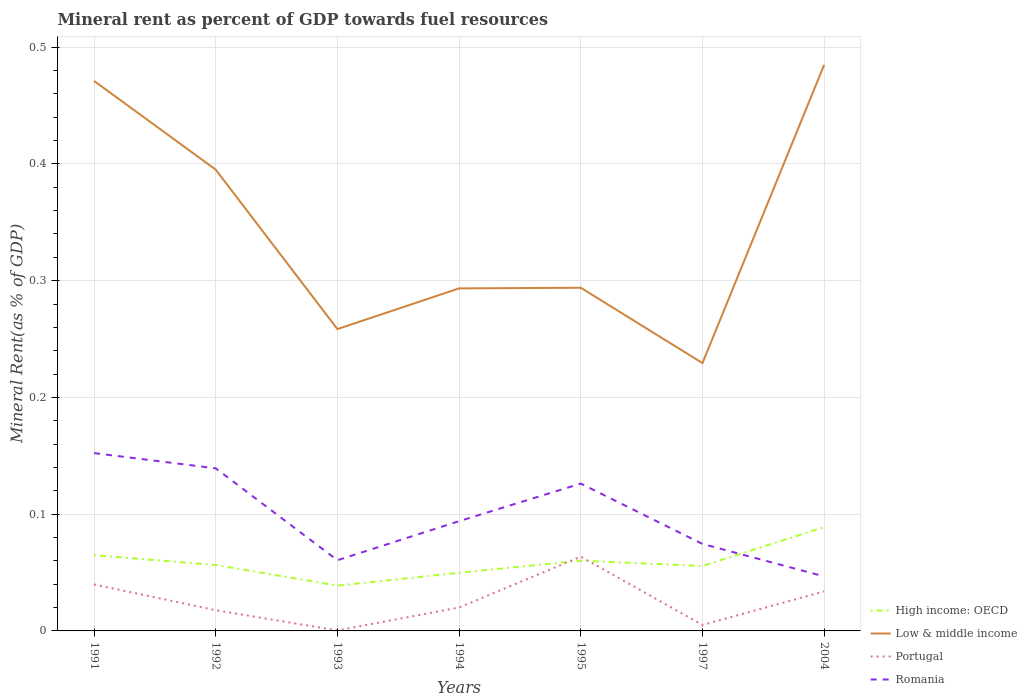Does the line corresponding to High income: OECD intersect with the line corresponding to Romania?
Provide a succinct answer. Yes. Is the number of lines equal to the number of legend labels?
Offer a very short reply. Yes. Across all years, what is the maximum mineral rent in Low & middle income?
Provide a succinct answer. 0.23. In which year was the mineral rent in High income: OECD maximum?
Make the answer very short. 1993. What is the total mineral rent in Romania in the graph?
Offer a terse response. 0.01. What is the difference between the highest and the second highest mineral rent in High income: OECD?
Provide a short and direct response. 0.05. Is the mineral rent in Romania strictly greater than the mineral rent in Low & middle income over the years?
Offer a terse response. Yes. How many lines are there?
Provide a short and direct response. 4. Are the values on the major ticks of Y-axis written in scientific E-notation?
Your answer should be compact. No. Does the graph contain grids?
Offer a very short reply. Yes. Where does the legend appear in the graph?
Your response must be concise. Bottom right. How many legend labels are there?
Make the answer very short. 4. How are the legend labels stacked?
Offer a very short reply. Vertical. What is the title of the graph?
Keep it short and to the point. Mineral rent as percent of GDP towards fuel resources. What is the label or title of the Y-axis?
Your answer should be very brief. Mineral Rent(as % of GDP). What is the Mineral Rent(as % of GDP) in High income: OECD in 1991?
Ensure brevity in your answer.  0.06. What is the Mineral Rent(as % of GDP) in Low & middle income in 1991?
Your response must be concise. 0.47. What is the Mineral Rent(as % of GDP) in Portugal in 1991?
Your answer should be compact. 0.04. What is the Mineral Rent(as % of GDP) of Romania in 1991?
Your answer should be compact. 0.15. What is the Mineral Rent(as % of GDP) in High income: OECD in 1992?
Your answer should be compact. 0.06. What is the Mineral Rent(as % of GDP) of Low & middle income in 1992?
Your answer should be very brief. 0.4. What is the Mineral Rent(as % of GDP) of Portugal in 1992?
Your response must be concise. 0.02. What is the Mineral Rent(as % of GDP) in Romania in 1992?
Provide a short and direct response. 0.14. What is the Mineral Rent(as % of GDP) of High income: OECD in 1993?
Make the answer very short. 0.04. What is the Mineral Rent(as % of GDP) of Low & middle income in 1993?
Your response must be concise. 0.26. What is the Mineral Rent(as % of GDP) of Portugal in 1993?
Your response must be concise. 0. What is the Mineral Rent(as % of GDP) in Romania in 1993?
Your answer should be very brief. 0.06. What is the Mineral Rent(as % of GDP) in High income: OECD in 1994?
Give a very brief answer. 0.05. What is the Mineral Rent(as % of GDP) of Low & middle income in 1994?
Your answer should be very brief. 0.29. What is the Mineral Rent(as % of GDP) of Portugal in 1994?
Ensure brevity in your answer.  0.02. What is the Mineral Rent(as % of GDP) of Romania in 1994?
Your response must be concise. 0.09. What is the Mineral Rent(as % of GDP) of High income: OECD in 1995?
Offer a terse response. 0.06. What is the Mineral Rent(as % of GDP) of Low & middle income in 1995?
Offer a terse response. 0.29. What is the Mineral Rent(as % of GDP) in Portugal in 1995?
Offer a terse response. 0.06. What is the Mineral Rent(as % of GDP) in Romania in 1995?
Give a very brief answer. 0.13. What is the Mineral Rent(as % of GDP) in High income: OECD in 1997?
Your answer should be very brief. 0.06. What is the Mineral Rent(as % of GDP) in Low & middle income in 1997?
Keep it short and to the point. 0.23. What is the Mineral Rent(as % of GDP) in Portugal in 1997?
Your response must be concise. 0.01. What is the Mineral Rent(as % of GDP) in Romania in 1997?
Provide a short and direct response. 0.07. What is the Mineral Rent(as % of GDP) of High income: OECD in 2004?
Keep it short and to the point. 0.09. What is the Mineral Rent(as % of GDP) of Low & middle income in 2004?
Your answer should be very brief. 0.48. What is the Mineral Rent(as % of GDP) of Portugal in 2004?
Offer a very short reply. 0.03. What is the Mineral Rent(as % of GDP) of Romania in 2004?
Ensure brevity in your answer.  0.05. Across all years, what is the maximum Mineral Rent(as % of GDP) of High income: OECD?
Keep it short and to the point. 0.09. Across all years, what is the maximum Mineral Rent(as % of GDP) of Low & middle income?
Your response must be concise. 0.48. Across all years, what is the maximum Mineral Rent(as % of GDP) of Portugal?
Your response must be concise. 0.06. Across all years, what is the maximum Mineral Rent(as % of GDP) of Romania?
Give a very brief answer. 0.15. Across all years, what is the minimum Mineral Rent(as % of GDP) of High income: OECD?
Your answer should be compact. 0.04. Across all years, what is the minimum Mineral Rent(as % of GDP) in Low & middle income?
Your response must be concise. 0.23. Across all years, what is the minimum Mineral Rent(as % of GDP) of Portugal?
Offer a very short reply. 0. Across all years, what is the minimum Mineral Rent(as % of GDP) in Romania?
Provide a short and direct response. 0.05. What is the total Mineral Rent(as % of GDP) in High income: OECD in the graph?
Your response must be concise. 0.41. What is the total Mineral Rent(as % of GDP) in Low & middle income in the graph?
Offer a very short reply. 2.43. What is the total Mineral Rent(as % of GDP) in Portugal in the graph?
Ensure brevity in your answer.  0.18. What is the total Mineral Rent(as % of GDP) of Romania in the graph?
Your answer should be very brief. 0.69. What is the difference between the Mineral Rent(as % of GDP) in High income: OECD in 1991 and that in 1992?
Make the answer very short. 0.01. What is the difference between the Mineral Rent(as % of GDP) in Low & middle income in 1991 and that in 1992?
Your answer should be compact. 0.08. What is the difference between the Mineral Rent(as % of GDP) of Portugal in 1991 and that in 1992?
Offer a terse response. 0.02. What is the difference between the Mineral Rent(as % of GDP) of Romania in 1991 and that in 1992?
Provide a succinct answer. 0.01. What is the difference between the Mineral Rent(as % of GDP) in High income: OECD in 1991 and that in 1993?
Your response must be concise. 0.03. What is the difference between the Mineral Rent(as % of GDP) of Low & middle income in 1991 and that in 1993?
Offer a very short reply. 0.21. What is the difference between the Mineral Rent(as % of GDP) of Portugal in 1991 and that in 1993?
Offer a very short reply. 0.04. What is the difference between the Mineral Rent(as % of GDP) of Romania in 1991 and that in 1993?
Offer a very short reply. 0.09. What is the difference between the Mineral Rent(as % of GDP) in High income: OECD in 1991 and that in 1994?
Give a very brief answer. 0.02. What is the difference between the Mineral Rent(as % of GDP) of Low & middle income in 1991 and that in 1994?
Ensure brevity in your answer.  0.18. What is the difference between the Mineral Rent(as % of GDP) of Portugal in 1991 and that in 1994?
Offer a very short reply. 0.02. What is the difference between the Mineral Rent(as % of GDP) in Romania in 1991 and that in 1994?
Provide a short and direct response. 0.06. What is the difference between the Mineral Rent(as % of GDP) in High income: OECD in 1991 and that in 1995?
Provide a succinct answer. 0. What is the difference between the Mineral Rent(as % of GDP) in Low & middle income in 1991 and that in 1995?
Give a very brief answer. 0.18. What is the difference between the Mineral Rent(as % of GDP) of Portugal in 1991 and that in 1995?
Ensure brevity in your answer.  -0.02. What is the difference between the Mineral Rent(as % of GDP) in Romania in 1991 and that in 1995?
Give a very brief answer. 0.03. What is the difference between the Mineral Rent(as % of GDP) in High income: OECD in 1991 and that in 1997?
Your answer should be very brief. 0.01. What is the difference between the Mineral Rent(as % of GDP) in Low & middle income in 1991 and that in 1997?
Ensure brevity in your answer.  0.24. What is the difference between the Mineral Rent(as % of GDP) of Portugal in 1991 and that in 1997?
Provide a short and direct response. 0.03. What is the difference between the Mineral Rent(as % of GDP) of Romania in 1991 and that in 1997?
Offer a terse response. 0.08. What is the difference between the Mineral Rent(as % of GDP) in High income: OECD in 1991 and that in 2004?
Your response must be concise. -0.02. What is the difference between the Mineral Rent(as % of GDP) of Low & middle income in 1991 and that in 2004?
Ensure brevity in your answer.  -0.01. What is the difference between the Mineral Rent(as % of GDP) in Portugal in 1991 and that in 2004?
Ensure brevity in your answer.  0.01. What is the difference between the Mineral Rent(as % of GDP) of Romania in 1991 and that in 2004?
Your answer should be very brief. 0.11. What is the difference between the Mineral Rent(as % of GDP) in High income: OECD in 1992 and that in 1993?
Offer a very short reply. 0.02. What is the difference between the Mineral Rent(as % of GDP) in Low & middle income in 1992 and that in 1993?
Your answer should be compact. 0.14. What is the difference between the Mineral Rent(as % of GDP) of Portugal in 1992 and that in 1993?
Provide a short and direct response. 0.02. What is the difference between the Mineral Rent(as % of GDP) in Romania in 1992 and that in 1993?
Your answer should be very brief. 0.08. What is the difference between the Mineral Rent(as % of GDP) of High income: OECD in 1992 and that in 1994?
Your response must be concise. 0.01. What is the difference between the Mineral Rent(as % of GDP) of Low & middle income in 1992 and that in 1994?
Offer a terse response. 0.1. What is the difference between the Mineral Rent(as % of GDP) of Portugal in 1992 and that in 1994?
Make the answer very short. -0. What is the difference between the Mineral Rent(as % of GDP) of Romania in 1992 and that in 1994?
Offer a very short reply. 0.05. What is the difference between the Mineral Rent(as % of GDP) in High income: OECD in 1992 and that in 1995?
Provide a succinct answer. -0. What is the difference between the Mineral Rent(as % of GDP) of Low & middle income in 1992 and that in 1995?
Give a very brief answer. 0.1. What is the difference between the Mineral Rent(as % of GDP) in Portugal in 1992 and that in 1995?
Give a very brief answer. -0.05. What is the difference between the Mineral Rent(as % of GDP) in Romania in 1992 and that in 1995?
Make the answer very short. 0.01. What is the difference between the Mineral Rent(as % of GDP) of High income: OECD in 1992 and that in 1997?
Your response must be concise. 0. What is the difference between the Mineral Rent(as % of GDP) in Low & middle income in 1992 and that in 1997?
Provide a succinct answer. 0.17. What is the difference between the Mineral Rent(as % of GDP) in Portugal in 1992 and that in 1997?
Your answer should be compact. 0.01. What is the difference between the Mineral Rent(as % of GDP) in Romania in 1992 and that in 1997?
Keep it short and to the point. 0.06. What is the difference between the Mineral Rent(as % of GDP) in High income: OECD in 1992 and that in 2004?
Make the answer very short. -0.03. What is the difference between the Mineral Rent(as % of GDP) in Low & middle income in 1992 and that in 2004?
Offer a very short reply. -0.09. What is the difference between the Mineral Rent(as % of GDP) of Portugal in 1992 and that in 2004?
Keep it short and to the point. -0.02. What is the difference between the Mineral Rent(as % of GDP) in Romania in 1992 and that in 2004?
Give a very brief answer. 0.09. What is the difference between the Mineral Rent(as % of GDP) of High income: OECD in 1993 and that in 1994?
Keep it short and to the point. -0.01. What is the difference between the Mineral Rent(as % of GDP) in Low & middle income in 1993 and that in 1994?
Offer a terse response. -0.03. What is the difference between the Mineral Rent(as % of GDP) in Portugal in 1993 and that in 1994?
Make the answer very short. -0.02. What is the difference between the Mineral Rent(as % of GDP) in Romania in 1993 and that in 1994?
Provide a short and direct response. -0.03. What is the difference between the Mineral Rent(as % of GDP) in High income: OECD in 1993 and that in 1995?
Ensure brevity in your answer.  -0.02. What is the difference between the Mineral Rent(as % of GDP) in Low & middle income in 1993 and that in 1995?
Keep it short and to the point. -0.04. What is the difference between the Mineral Rent(as % of GDP) in Portugal in 1993 and that in 1995?
Give a very brief answer. -0.06. What is the difference between the Mineral Rent(as % of GDP) of Romania in 1993 and that in 1995?
Keep it short and to the point. -0.07. What is the difference between the Mineral Rent(as % of GDP) in High income: OECD in 1993 and that in 1997?
Give a very brief answer. -0.02. What is the difference between the Mineral Rent(as % of GDP) of Low & middle income in 1993 and that in 1997?
Your response must be concise. 0.03. What is the difference between the Mineral Rent(as % of GDP) in Portugal in 1993 and that in 1997?
Your answer should be compact. -0. What is the difference between the Mineral Rent(as % of GDP) in Romania in 1993 and that in 1997?
Offer a terse response. -0.01. What is the difference between the Mineral Rent(as % of GDP) of High income: OECD in 1993 and that in 2004?
Keep it short and to the point. -0.05. What is the difference between the Mineral Rent(as % of GDP) in Low & middle income in 1993 and that in 2004?
Your answer should be compact. -0.23. What is the difference between the Mineral Rent(as % of GDP) in Portugal in 1993 and that in 2004?
Your response must be concise. -0.03. What is the difference between the Mineral Rent(as % of GDP) in Romania in 1993 and that in 2004?
Make the answer very short. 0.01. What is the difference between the Mineral Rent(as % of GDP) of High income: OECD in 1994 and that in 1995?
Your response must be concise. -0.01. What is the difference between the Mineral Rent(as % of GDP) of Low & middle income in 1994 and that in 1995?
Give a very brief answer. -0. What is the difference between the Mineral Rent(as % of GDP) in Portugal in 1994 and that in 1995?
Your answer should be compact. -0.04. What is the difference between the Mineral Rent(as % of GDP) of Romania in 1994 and that in 1995?
Your answer should be compact. -0.03. What is the difference between the Mineral Rent(as % of GDP) of High income: OECD in 1994 and that in 1997?
Your answer should be compact. -0.01. What is the difference between the Mineral Rent(as % of GDP) of Low & middle income in 1994 and that in 1997?
Make the answer very short. 0.06. What is the difference between the Mineral Rent(as % of GDP) in Portugal in 1994 and that in 1997?
Provide a short and direct response. 0.01. What is the difference between the Mineral Rent(as % of GDP) of Romania in 1994 and that in 1997?
Give a very brief answer. 0.02. What is the difference between the Mineral Rent(as % of GDP) of High income: OECD in 1994 and that in 2004?
Your answer should be compact. -0.04. What is the difference between the Mineral Rent(as % of GDP) of Low & middle income in 1994 and that in 2004?
Your answer should be very brief. -0.19. What is the difference between the Mineral Rent(as % of GDP) of Portugal in 1994 and that in 2004?
Give a very brief answer. -0.01. What is the difference between the Mineral Rent(as % of GDP) of Romania in 1994 and that in 2004?
Keep it short and to the point. 0.05. What is the difference between the Mineral Rent(as % of GDP) in High income: OECD in 1995 and that in 1997?
Offer a very short reply. 0. What is the difference between the Mineral Rent(as % of GDP) in Low & middle income in 1995 and that in 1997?
Give a very brief answer. 0.06. What is the difference between the Mineral Rent(as % of GDP) of Portugal in 1995 and that in 1997?
Make the answer very short. 0.06. What is the difference between the Mineral Rent(as % of GDP) in Romania in 1995 and that in 1997?
Provide a succinct answer. 0.05. What is the difference between the Mineral Rent(as % of GDP) of High income: OECD in 1995 and that in 2004?
Provide a short and direct response. -0.03. What is the difference between the Mineral Rent(as % of GDP) of Low & middle income in 1995 and that in 2004?
Provide a succinct answer. -0.19. What is the difference between the Mineral Rent(as % of GDP) in Portugal in 1995 and that in 2004?
Your answer should be compact. 0.03. What is the difference between the Mineral Rent(as % of GDP) of Romania in 1995 and that in 2004?
Offer a very short reply. 0.08. What is the difference between the Mineral Rent(as % of GDP) in High income: OECD in 1997 and that in 2004?
Provide a short and direct response. -0.03. What is the difference between the Mineral Rent(as % of GDP) in Low & middle income in 1997 and that in 2004?
Ensure brevity in your answer.  -0.26. What is the difference between the Mineral Rent(as % of GDP) of Portugal in 1997 and that in 2004?
Make the answer very short. -0.03. What is the difference between the Mineral Rent(as % of GDP) of Romania in 1997 and that in 2004?
Your answer should be very brief. 0.03. What is the difference between the Mineral Rent(as % of GDP) of High income: OECD in 1991 and the Mineral Rent(as % of GDP) of Low & middle income in 1992?
Your response must be concise. -0.33. What is the difference between the Mineral Rent(as % of GDP) of High income: OECD in 1991 and the Mineral Rent(as % of GDP) of Portugal in 1992?
Your response must be concise. 0.05. What is the difference between the Mineral Rent(as % of GDP) of High income: OECD in 1991 and the Mineral Rent(as % of GDP) of Romania in 1992?
Provide a succinct answer. -0.07. What is the difference between the Mineral Rent(as % of GDP) of Low & middle income in 1991 and the Mineral Rent(as % of GDP) of Portugal in 1992?
Give a very brief answer. 0.45. What is the difference between the Mineral Rent(as % of GDP) of Low & middle income in 1991 and the Mineral Rent(as % of GDP) of Romania in 1992?
Offer a terse response. 0.33. What is the difference between the Mineral Rent(as % of GDP) in Portugal in 1991 and the Mineral Rent(as % of GDP) in Romania in 1992?
Your answer should be very brief. -0.1. What is the difference between the Mineral Rent(as % of GDP) in High income: OECD in 1991 and the Mineral Rent(as % of GDP) in Low & middle income in 1993?
Offer a terse response. -0.19. What is the difference between the Mineral Rent(as % of GDP) in High income: OECD in 1991 and the Mineral Rent(as % of GDP) in Portugal in 1993?
Provide a succinct answer. 0.06. What is the difference between the Mineral Rent(as % of GDP) of High income: OECD in 1991 and the Mineral Rent(as % of GDP) of Romania in 1993?
Give a very brief answer. 0. What is the difference between the Mineral Rent(as % of GDP) of Low & middle income in 1991 and the Mineral Rent(as % of GDP) of Portugal in 1993?
Your response must be concise. 0.47. What is the difference between the Mineral Rent(as % of GDP) in Low & middle income in 1991 and the Mineral Rent(as % of GDP) in Romania in 1993?
Ensure brevity in your answer.  0.41. What is the difference between the Mineral Rent(as % of GDP) in Portugal in 1991 and the Mineral Rent(as % of GDP) in Romania in 1993?
Provide a succinct answer. -0.02. What is the difference between the Mineral Rent(as % of GDP) in High income: OECD in 1991 and the Mineral Rent(as % of GDP) in Low & middle income in 1994?
Make the answer very short. -0.23. What is the difference between the Mineral Rent(as % of GDP) in High income: OECD in 1991 and the Mineral Rent(as % of GDP) in Portugal in 1994?
Offer a very short reply. 0.04. What is the difference between the Mineral Rent(as % of GDP) in High income: OECD in 1991 and the Mineral Rent(as % of GDP) in Romania in 1994?
Your answer should be very brief. -0.03. What is the difference between the Mineral Rent(as % of GDP) of Low & middle income in 1991 and the Mineral Rent(as % of GDP) of Portugal in 1994?
Give a very brief answer. 0.45. What is the difference between the Mineral Rent(as % of GDP) in Low & middle income in 1991 and the Mineral Rent(as % of GDP) in Romania in 1994?
Keep it short and to the point. 0.38. What is the difference between the Mineral Rent(as % of GDP) of Portugal in 1991 and the Mineral Rent(as % of GDP) of Romania in 1994?
Your response must be concise. -0.05. What is the difference between the Mineral Rent(as % of GDP) of High income: OECD in 1991 and the Mineral Rent(as % of GDP) of Low & middle income in 1995?
Your answer should be compact. -0.23. What is the difference between the Mineral Rent(as % of GDP) of High income: OECD in 1991 and the Mineral Rent(as % of GDP) of Portugal in 1995?
Keep it short and to the point. 0. What is the difference between the Mineral Rent(as % of GDP) in High income: OECD in 1991 and the Mineral Rent(as % of GDP) in Romania in 1995?
Provide a succinct answer. -0.06. What is the difference between the Mineral Rent(as % of GDP) of Low & middle income in 1991 and the Mineral Rent(as % of GDP) of Portugal in 1995?
Provide a short and direct response. 0.41. What is the difference between the Mineral Rent(as % of GDP) of Low & middle income in 1991 and the Mineral Rent(as % of GDP) of Romania in 1995?
Ensure brevity in your answer.  0.34. What is the difference between the Mineral Rent(as % of GDP) in Portugal in 1991 and the Mineral Rent(as % of GDP) in Romania in 1995?
Keep it short and to the point. -0.09. What is the difference between the Mineral Rent(as % of GDP) of High income: OECD in 1991 and the Mineral Rent(as % of GDP) of Low & middle income in 1997?
Keep it short and to the point. -0.16. What is the difference between the Mineral Rent(as % of GDP) of High income: OECD in 1991 and the Mineral Rent(as % of GDP) of Portugal in 1997?
Your response must be concise. 0.06. What is the difference between the Mineral Rent(as % of GDP) in High income: OECD in 1991 and the Mineral Rent(as % of GDP) in Romania in 1997?
Offer a very short reply. -0.01. What is the difference between the Mineral Rent(as % of GDP) in Low & middle income in 1991 and the Mineral Rent(as % of GDP) in Portugal in 1997?
Your response must be concise. 0.47. What is the difference between the Mineral Rent(as % of GDP) in Low & middle income in 1991 and the Mineral Rent(as % of GDP) in Romania in 1997?
Your answer should be very brief. 0.4. What is the difference between the Mineral Rent(as % of GDP) of Portugal in 1991 and the Mineral Rent(as % of GDP) of Romania in 1997?
Provide a succinct answer. -0.03. What is the difference between the Mineral Rent(as % of GDP) in High income: OECD in 1991 and the Mineral Rent(as % of GDP) in Low & middle income in 2004?
Make the answer very short. -0.42. What is the difference between the Mineral Rent(as % of GDP) in High income: OECD in 1991 and the Mineral Rent(as % of GDP) in Portugal in 2004?
Provide a succinct answer. 0.03. What is the difference between the Mineral Rent(as % of GDP) of High income: OECD in 1991 and the Mineral Rent(as % of GDP) of Romania in 2004?
Give a very brief answer. 0.02. What is the difference between the Mineral Rent(as % of GDP) of Low & middle income in 1991 and the Mineral Rent(as % of GDP) of Portugal in 2004?
Your response must be concise. 0.44. What is the difference between the Mineral Rent(as % of GDP) in Low & middle income in 1991 and the Mineral Rent(as % of GDP) in Romania in 2004?
Give a very brief answer. 0.42. What is the difference between the Mineral Rent(as % of GDP) of Portugal in 1991 and the Mineral Rent(as % of GDP) of Romania in 2004?
Offer a terse response. -0.01. What is the difference between the Mineral Rent(as % of GDP) in High income: OECD in 1992 and the Mineral Rent(as % of GDP) in Low & middle income in 1993?
Ensure brevity in your answer.  -0.2. What is the difference between the Mineral Rent(as % of GDP) in High income: OECD in 1992 and the Mineral Rent(as % of GDP) in Portugal in 1993?
Your response must be concise. 0.06. What is the difference between the Mineral Rent(as % of GDP) in High income: OECD in 1992 and the Mineral Rent(as % of GDP) in Romania in 1993?
Provide a succinct answer. -0. What is the difference between the Mineral Rent(as % of GDP) in Low & middle income in 1992 and the Mineral Rent(as % of GDP) in Portugal in 1993?
Your answer should be compact. 0.39. What is the difference between the Mineral Rent(as % of GDP) of Low & middle income in 1992 and the Mineral Rent(as % of GDP) of Romania in 1993?
Your response must be concise. 0.33. What is the difference between the Mineral Rent(as % of GDP) of Portugal in 1992 and the Mineral Rent(as % of GDP) of Romania in 1993?
Offer a very short reply. -0.04. What is the difference between the Mineral Rent(as % of GDP) of High income: OECD in 1992 and the Mineral Rent(as % of GDP) of Low & middle income in 1994?
Give a very brief answer. -0.24. What is the difference between the Mineral Rent(as % of GDP) of High income: OECD in 1992 and the Mineral Rent(as % of GDP) of Portugal in 1994?
Your answer should be compact. 0.04. What is the difference between the Mineral Rent(as % of GDP) in High income: OECD in 1992 and the Mineral Rent(as % of GDP) in Romania in 1994?
Offer a very short reply. -0.04. What is the difference between the Mineral Rent(as % of GDP) of Low & middle income in 1992 and the Mineral Rent(as % of GDP) of Romania in 1994?
Offer a very short reply. 0.3. What is the difference between the Mineral Rent(as % of GDP) in Portugal in 1992 and the Mineral Rent(as % of GDP) in Romania in 1994?
Your response must be concise. -0.08. What is the difference between the Mineral Rent(as % of GDP) of High income: OECD in 1992 and the Mineral Rent(as % of GDP) of Low & middle income in 1995?
Provide a short and direct response. -0.24. What is the difference between the Mineral Rent(as % of GDP) in High income: OECD in 1992 and the Mineral Rent(as % of GDP) in Portugal in 1995?
Provide a succinct answer. -0.01. What is the difference between the Mineral Rent(as % of GDP) in High income: OECD in 1992 and the Mineral Rent(as % of GDP) in Romania in 1995?
Your answer should be very brief. -0.07. What is the difference between the Mineral Rent(as % of GDP) in Low & middle income in 1992 and the Mineral Rent(as % of GDP) in Portugal in 1995?
Your answer should be compact. 0.33. What is the difference between the Mineral Rent(as % of GDP) of Low & middle income in 1992 and the Mineral Rent(as % of GDP) of Romania in 1995?
Give a very brief answer. 0.27. What is the difference between the Mineral Rent(as % of GDP) in Portugal in 1992 and the Mineral Rent(as % of GDP) in Romania in 1995?
Your answer should be compact. -0.11. What is the difference between the Mineral Rent(as % of GDP) in High income: OECD in 1992 and the Mineral Rent(as % of GDP) in Low & middle income in 1997?
Offer a very short reply. -0.17. What is the difference between the Mineral Rent(as % of GDP) of High income: OECD in 1992 and the Mineral Rent(as % of GDP) of Portugal in 1997?
Ensure brevity in your answer.  0.05. What is the difference between the Mineral Rent(as % of GDP) of High income: OECD in 1992 and the Mineral Rent(as % of GDP) of Romania in 1997?
Provide a succinct answer. -0.02. What is the difference between the Mineral Rent(as % of GDP) of Low & middle income in 1992 and the Mineral Rent(as % of GDP) of Portugal in 1997?
Your answer should be compact. 0.39. What is the difference between the Mineral Rent(as % of GDP) of Low & middle income in 1992 and the Mineral Rent(as % of GDP) of Romania in 1997?
Provide a short and direct response. 0.32. What is the difference between the Mineral Rent(as % of GDP) of Portugal in 1992 and the Mineral Rent(as % of GDP) of Romania in 1997?
Ensure brevity in your answer.  -0.06. What is the difference between the Mineral Rent(as % of GDP) in High income: OECD in 1992 and the Mineral Rent(as % of GDP) in Low & middle income in 2004?
Provide a succinct answer. -0.43. What is the difference between the Mineral Rent(as % of GDP) in High income: OECD in 1992 and the Mineral Rent(as % of GDP) in Portugal in 2004?
Offer a terse response. 0.02. What is the difference between the Mineral Rent(as % of GDP) in High income: OECD in 1992 and the Mineral Rent(as % of GDP) in Romania in 2004?
Provide a succinct answer. 0.01. What is the difference between the Mineral Rent(as % of GDP) in Low & middle income in 1992 and the Mineral Rent(as % of GDP) in Portugal in 2004?
Provide a short and direct response. 0.36. What is the difference between the Mineral Rent(as % of GDP) of Low & middle income in 1992 and the Mineral Rent(as % of GDP) of Romania in 2004?
Your answer should be very brief. 0.35. What is the difference between the Mineral Rent(as % of GDP) in Portugal in 1992 and the Mineral Rent(as % of GDP) in Romania in 2004?
Provide a succinct answer. -0.03. What is the difference between the Mineral Rent(as % of GDP) in High income: OECD in 1993 and the Mineral Rent(as % of GDP) in Low & middle income in 1994?
Keep it short and to the point. -0.25. What is the difference between the Mineral Rent(as % of GDP) in High income: OECD in 1993 and the Mineral Rent(as % of GDP) in Portugal in 1994?
Give a very brief answer. 0.02. What is the difference between the Mineral Rent(as % of GDP) of High income: OECD in 1993 and the Mineral Rent(as % of GDP) of Romania in 1994?
Make the answer very short. -0.06. What is the difference between the Mineral Rent(as % of GDP) of Low & middle income in 1993 and the Mineral Rent(as % of GDP) of Portugal in 1994?
Make the answer very short. 0.24. What is the difference between the Mineral Rent(as % of GDP) of Low & middle income in 1993 and the Mineral Rent(as % of GDP) of Romania in 1994?
Keep it short and to the point. 0.16. What is the difference between the Mineral Rent(as % of GDP) in Portugal in 1993 and the Mineral Rent(as % of GDP) in Romania in 1994?
Your answer should be compact. -0.09. What is the difference between the Mineral Rent(as % of GDP) in High income: OECD in 1993 and the Mineral Rent(as % of GDP) in Low & middle income in 1995?
Provide a succinct answer. -0.26. What is the difference between the Mineral Rent(as % of GDP) of High income: OECD in 1993 and the Mineral Rent(as % of GDP) of Portugal in 1995?
Ensure brevity in your answer.  -0.02. What is the difference between the Mineral Rent(as % of GDP) in High income: OECD in 1993 and the Mineral Rent(as % of GDP) in Romania in 1995?
Make the answer very short. -0.09. What is the difference between the Mineral Rent(as % of GDP) of Low & middle income in 1993 and the Mineral Rent(as % of GDP) of Portugal in 1995?
Offer a very short reply. 0.19. What is the difference between the Mineral Rent(as % of GDP) of Low & middle income in 1993 and the Mineral Rent(as % of GDP) of Romania in 1995?
Provide a short and direct response. 0.13. What is the difference between the Mineral Rent(as % of GDP) of Portugal in 1993 and the Mineral Rent(as % of GDP) of Romania in 1995?
Keep it short and to the point. -0.13. What is the difference between the Mineral Rent(as % of GDP) of High income: OECD in 1993 and the Mineral Rent(as % of GDP) of Low & middle income in 1997?
Give a very brief answer. -0.19. What is the difference between the Mineral Rent(as % of GDP) of High income: OECD in 1993 and the Mineral Rent(as % of GDP) of Portugal in 1997?
Your answer should be very brief. 0.03. What is the difference between the Mineral Rent(as % of GDP) in High income: OECD in 1993 and the Mineral Rent(as % of GDP) in Romania in 1997?
Offer a terse response. -0.04. What is the difference between the Mineral Rent(as % of GDP) of Low & middle income in 1993 and the Mineral Rent(as % of GDP) of Portugal in 1997?
Keep it short and to the point. 0.25. What is the difference between the Mineral Rent(as % of GDP) in Low & middle income in 1993 and the Mineral Rent(as % of GDP) in Romania in 1997?
Your answer should be compact. 0.18. What is the difference between the Mineral Rent(as % of GDP) of Portugal in 1993 and the Mineral Rent(as % of GDP) of Romania in 1997?
Your answer should be very brief. -0.07. What is the difference between the Mineral Rent(as % of GDP) of High income: OECD in 1993 and the Mineral Rent(as % of GDP) of Low & middle income in 2004?
Provide a succinct answer. -0.45. What is the difference between the Mineral Rent(as % of GDP) of High income: OECD in 1993 and the Mineral Rent(as % of GDP) of Portugal in 2004?
Your answer should be very brief. 0.01. What is the difference between the Mineral Rent(as % of GDP) of High income: OECD in 1993 and the Mineral Rent(as % of GDP) of Romania in 2004?
Your answer should be very brief. -0.01. What is the difference between the Mineral Rent(as % of GDP) of Low & middle income in 1993 and the Mineral Rent(as % of GDP) of Portugal in 2004?
Provide a short and direct response. 0.22. What is the difference between the Mineral Rent(as % of GDP) of Low & middle income in 1993 and the Mineral Rent(as % of GDP) of Romania in 2004?
Make the answer very short. 0.21. What is the difference between the Mineral Rent(as % of GDP) in Portugal in 1993 and the Mineral Rent(as % of GDP) in Romania in 2004?
Provide a short and direct response. -0.05. What is the difference between the Mineral Rent(as % of GDP) of High income: OECD in 1994 and the Mineral Rent(as % of GDP) of Low & middle income in 1995?
Your response must be concise. -0.24. What is the difference between the Mineral Rent(as % of GDP) of High income: OECD in 1994 and the Mineral Rent(as % of GDP) of Portugal in 1995?
Your answer should be very brief. -0.01. What is the difference between the Mineral Rent(as % of GDP) in High income: OECD in 1994 and the Mineral Rent(as % of GDP) in Romania in 1995?
Your answer should be compact. -0.08. What is the difference between the Mineral Rent(as % of GDP) in Low & middle income in 1994 and the Mineral Rent(as % of GDP) in Portugal in 1995?
Give a very brief answer. 0.23. What is the difference between the Mineral Rent(as % of GDP) of Low & middle income in 1994 and the Mineral Rent(as % of GDP) of Romania in 1995?
Provide a succinct answer. 0.17. What is the difference between the Mineral Rent(as % of GDP) in Portugal in 1994 and the Mineral Rent(as % of GDP) in Romania in 1995?
Ensure brevity in your answer.  -0.11. What is the difference between the Mineral Rent(as % of GDP) in High income: OECD in 1994 and the Mineral Rent(as % of GDP) in Low & middle income in 1997?
Keep it short and to the point. -0.18. What is the difference between the Mineral Rent(as % of GDP) in High income: OECD in 1994 and the Mineral Rent(as % of GDP) in Portugal in 1997?
Ensure brevity in your answer.  0.04. What is the difference between the Mineral Rent(as % of GDP) of High income: OECD in 1994 and the Mineral Rent(as % of GDP) of Romania in 1997?
Your response must be concise. -0.02. What is the difference between the Mineral Rent(as % of GDP) of Low & middle income in 1994 and the Mineral Rent(as % of GDP) of Portugal in 1997?
Make the answer very short. 0.29. What is the difference between the Mineral Rent(as % of GDP) of Low & middle income in 1994 and the Mineral Rent(as % of GDP) of Romania in 1997?
Provide a short and direct response. 0.22. What is the difference between the Mineral Rent(as % of GDP) of Portugal in 1994 and the Mineral Rent(as % of GDP) of Romania in 1997?
Offer a very short reply. -0.05. What is the difference between the Mineral Rent(as % of GDP) in High income: OECD in 1994 and the Mineral Rent(as % of GDP) in Low & middle income in 2004?
Offer a very short reply. -0.43. What is the difference between the Mineral Rent(as % of GDP) of High income: OECD in 1994 and the Mineral Rent(as % of GDP) of Portugal in 2004?
Your answer should be very brief. 0.02. What is the difference between the Mineral Rent(as % of GDP) of High income: OECD in 1994 and the Mineral Rent(as % of GDP) of Romania in 2004?
Give a very brief answer. 0. What is the difference between the Mineral Rent(as % of GDP) of Low & middle income in 1994 and the Mineral Rent(as % of GDP) of Portugal in 2004?
Offer a very short reply. 0.26. What is the difference between the Mineral Rent(as % of GDP) in Low & middle income in 1994 and the Mineral Rent(as % of GDP) in Romania in 2004?
Ensure brevity in your answer.  0.25. What is the difference between the Mineral Rent(as % of GDP) in Portugal in 1994 and the Mineral Rent(as % of GDP) in Romania in 2004?
Your answer should be compact. -0.03. What is the difference between the Mineral Rent(as % of GDP) in High income: OECD in 1995 and the Mineral Rent(as % of GDP) in Low & middle income in 1997?
Offer a terse response. -0.17. What is the difference between the Mineral Rent(as % of GDP) of High income: OECD in 1995 and the Mineral Rent(as % of GDP) of Portugal in 1997?
Provide a succinct answer. 0.06. What is the difference between the Mineral Rent(as % of GDP) in High income: OECD in 1995 and the Mineral Rent(as % of GDP) in Romania in 1997?
Offer a terse response. -0.01. What is the difference between the Mineral Rent(as % of GDP) of Low & middle income in 1995 and the Mineral Rent(as % of GDP) of Portugal in 1997?
Provide a succinct answer. 0.29. What is the difference between the Mineral Rent(as % of GDP) in Low & middle income in 1995 and the Mineral Rent(as % of GDP) in Romania in 1997?
Make the answer very short. 0.22. What is the difference between the Mineral Rent(as % of GDP) in Portugal in 1995 and the Mineral Rent(as % of GDP) in Romania in 1997?
Ensure brevity in your answer.  -0.01. What is the difference between the Mineral Rent(as % of GDP) in High income: OECD in 1995 and the Mineral Rent(as % of GDP) in Low & middle income in 2004?
Your answer should be very brief. -0.42. What is the difference between the Mineral Rent(as % of GDP) of High income: OECD in 1995 and the Mineral Rent(as % of GDP) of Portugal in 2004?
Your answer should be very brief. 0.03. What is the difference between the Mineral Rent(as % of GDP) of High income: OECD in 1995 and the Mineral Rent(as % of GDP) of Romania in 2004?
Provide a succinct answer. 0.01. What is the difference between the Mineral Rent(as % of GDP) of Low & middle income in 1995 and the Mineral Rent(as % of GDP) of Portugal in 2004?
Keep it short and to the point. 0.26. What is the difference between the Mineral Rent(as % of GDP) in Low & middle income in 1995 and the Mineral Rent(as % of GDP) in Romania in 2004?
Keep it short and to the point. 0.25. What is the difference between the Mineral Rent(as % of GDP) of Portugal in 1995 and the Mineral Rent(as % of GDP) of Romania in 2004?
Your response must be concise. 0.02. What is the difference between the Mineral Rent(as % of GDP) in High income: OECD in 1997 and the Mineral Rent(as % of GDP) in Low & middle income in 2004?
Keep it short and to the point. -0.43. What is the difference between the Mineral Rent(as % of GDP) in High income: OECD in 1997 and the Mineral Rent(as % of GDP) in Portugal in 2004?
Give a very brief answer. 0.02. What is the difference between the Mineral Rent(as % of GDP) of High income: OECD in 1997 and the Mineral Rent(as % of GDP) of Romania in 2004?
Make the answer very short. 0.01. What is the difference between the Mineral Rent(as % of GDP) of Low & middle income in 1997 and the Mineral Rent(as % of GDP) of Portugal in 2004?
Your response must be concise. 0.2. What is the difference between the Mineral Rent(as % of GDP) of Low & middle income in 1997 and the Mineral Rent(as % of GDP) of Romania in 2004?
Your response must be concise. 0.18. What is the difference between the Mineral Rent(as % of GDP) of Portugal in 1997 and the Mineral Rent(as % of GDP) of Romania in 2004?
Provide a short and direct response. -0.04. What is the average Mineral Rent(as % of GDP) of High income: OECD per year?
Give a very brief answer. 0.06. What is the average Mineral Rent(as % of GDP) in Low & middle income per year?
Keep it short and to the point. 0.35. What is the average Mineral Rent(as % of GDP) in Portugal per year?
Make the answer very short. 0.03. What is the average Mineral Rent(as % of GDP) in Romania per year?
Your answer should be very brief. 0.1. In the year 1991, what is the difference between the Mineral Rent(as % of GDP) in High income: OECD and Mineral Rent(as % of GDP) in Low & middle income?
Provide a short and direct response. -0.41. In the year 1991, what is the difference between the Mineral Rent(as % of GDP) in High income: OECD and Mineral Rent(as % of GDP) in Portugal?
Provide a succinct answer. 0.03. In the year 1991, what is the difference between the Mineral Rent(as % of GDP) in High income: OECD and Mineral Rent(as % of GDP) in Romania?
Make the answer very short. -0.09. In the year 1991, what is the difference between the Mineral Rent(as % of GDP) in Low & middle income and Mineral Rent(as % of GDP) in Portugal?
Your answer should be compact. 0.43. In the year 1991, what is the difference between the Mineral Rent(as % of GDP) in Low & middle income and Mineral Rent(as % of GDP) in Romania?
Ensure brevity in your answer.  0.32. In the year 1991, what is the difference between the Mineral Rent(as % of GDP) of Portugal and Mineral Rent(as % of GDP) of Romania?
Offer a terse response. -0.11. In the year 1992, what is the difference between the Mineral Rent(as % of GDP) of High income: OECD and Mineral Rent(as % of GDP) of Low & middle income?
Your answer should be very brief. -0.34. In the year 1992, what is the difference between the Mineral Rent(as % of GDP) in High income: OECD and Mineral Rent(as % of GDP) in Portugal?
Offer a very short reply. 0.04. In the year 1992, what is the difference between the Mineral Rent(as % of GDP) of High income: OECD and Mineral Rent(as % of GDP) of Romania?
Offer a terse response. -0.08. In the year 1992, what is the difference between the Mineral Rent(as % of GDP) of Low & middle income and Mineral Rent(as % of GDP) of Portugal?
Provide a succinct answer. 0.38. In the year 1992, what is the difference between the Mineral Rent(as % of GDP) of Low & middle income and Mineral Rent(as % of GDP) of Romania?
Your answer should be very brief. 0.26. In the year 1992, what is the difference between the Mineral Rent(as % of GDP) of Portugal and Mineral Rent(as % of GDP) of Romania?
Keep it short and to the point. -0.12. In the year 1993, what is the difference between the Mineral Rent(as % of GDP) of High income: OECD and Mineral Rent(as % of GDP) of Low & middle income?
Provide a succinct answer. -0.22. In the year 1993, what is the difference between the Mineral Rent(as % of GDP) of High income: OECD and Mineral Rent(as % of GDP) of Portugal?
Your answer should be very brief. 0.04. In the year 1993, what is the difference between the Mineral Rent(as % of GDP) of High income: OECD and Mineral Rent(as % of GDP) of Romania?
Give a very brief answer. -0.02. In the year 1993, what is the difference between the Mineral Rent(as % of GDP) in Low & middle income and Mineral Rent(as % of GDP) in Portugal?
Provide a short and direct response. 0.26. In the year 1993, what is the difference between the Mineral Rent(as % of GDP) in Low & middle income and Mineral Rent(as % of GDP) in Romania?
Provide a succinct answer. 0.2. In the year 1993, what is the difference between the Mineral Rent(as % of GDP) of Portugal and Mineral Rent(as % of GDP) of Romania?
Your answer should be very brief. -0.06. In the year 1994, what is the difference between the Mineral Rent(as % of GDP) of High income: OECD and Mineral Rent(as % of GDP) of Low & middle income?
Provide a succinct answer. -0.24. In the year 1994, what is the difference between the Mineral Rent(as % of GDP) in High income: OECD and Mineral Rent(as % of GDP) in Portugal?
Your answer should be very brief. 0.03. In the year 1994, what is the difference between the Mineral Rent(as % of GDP) in High income: OECD and Mineral Rent(as % of GDP) in Romania?
Offer a very short reply. -0.04. In the year 1994, what is the difference between the Mineral Rent(as % of GDP) of Low & middle income and Mineral Rent(as % of GDP) of Portugal?
Offer a very short reply. 0.27. In the year 1994, what is the difference between the Mineral Rent(as % of GDP) in Low & middle income and Mineral Rent(as % of GDP) in Romania?
Ensure brevity in your answer.  0.2. In the year 1994, what is the difference between the Mineral Rent(as % of GDP) of Portugal and Mineral Rent(as % of GDP) of Romania?
Ensure brevity in your answer.  -0.07. In the year 1995, what is the difference between the Mineral Rent(as % of GDP) of High income: OECD and Mineral Rent(as % of GDP) of Low & middle income?
Your answer should be very brief. -0.23. In the year 1995, what is the difference between the Mineral Rent(as % of GDP) in High income: OECD and Mineral Rent(as % of GDP) in Portugal?
Make the answer very short. -0. In the year 1995, what is the difference between the Mineral Rent(as % of GDP) of High income: OECD and Mineral Rent(as % of GDP) of Romania?
Provide a short and direct response. -0.07. In the year 1995, what is the difference between the Mineral Rent(as % of GDP) in Low & middle income and Mineral Rent(as % of GDP) in Portugal?
Your answer should be compact. 0.23. In the year 1995, what is the difference between the Mineral Rent(as % of GDP) in Low & middle income and Mineral Rent(as % of GDP) in Romania?
Your answer should be compact. 0.17. In the year 1995, what is the difference between the Mineral Rent(as % of GDP) of Portugal and Mineral Rent(as % of GDP) of Romania?
Give a very brief answer. -0.06. In the year 1997, what is the difference between the Mineral Rent(as % of GDP) in High income: OECD and Mineral Rent(as % of GDP) in Low & middle income?
Ensure brevity in your answer.  -0.17. In the year 1997, what is the difference between the Mineral Rent(as % of GDP) in High income: OECD and Mineral Rent(as % of GDP) in Portugal?
Make the answer very short. 0.05. In the year 1997, what is the difference between the Mineral Rent(as % of GDP) of High income: OECD and Mineral Rent(as % of GDP) of Romania?
Keep it short and to the point. -0.02. In the year 1997, what is the difference between the Mineral Rent(as % of GDP) of Low & middle income and Mineral Rent(as % of GDP) of Portugal?
Give a very brief answer. 0.22. In the year 1997, what is the difference between the Mineral Rent(as % of GDP) of Low & middle income and Mineral Rent(as % of GDP) of Romania?
Provide a succinct answer. 0.15. In the year 1997, what is the difference between the Mineral Rent(as % of GDP) of Portugal and Mineral Rent(as % of GDP) of Romania?
Your response must be concise. -0.07. In the year 2004, what is the difference between the Mineral Rent(as % of GDP) of High income: OECD and Mineral Rent(as % of GDP) of Low & middle income?
Keep it short and to the point. -0.4. In the year 2004, what is the difference between the Mineral Rent(as % of GDP) in High income: OECD and Mineral Rent(as % of GDP) in Portugal?
Make the answer very short. 0.06. In the year 2004, what is the difference between the Mineral Rent(as % of GDP) in High income: OECD and Mineral Rent(as % of GDP) in Romania?
Your response must be concise. 0.04. In the year 2004, what is the difference between the Mineral Rent(as % of GDP) of Low & middle income and Mineral Rent(as % of GDP) of Portugal?
Your response must be concise. 0.45. In the year 2004, what is the difference between the Mineral Rent(as % of GDP) of Low & middle income and Mineral Rent(as % of GDP) of Romania?
Give a very brief answer. 0.44. In the year 2004, what is the difference between the Mineral Rent(as % of GDP) in Portugal and Mineral Rent(as % of GDP) in Romania?
Give a very brief answer. -0.01. What is the ratio of the Mineral Rent(as % of GDP) of High income: OECD in 1991 to that in 1992?
Your answer should be compact. 1.15. What is the ratio of the Mineral Rent(as % of GDP) in Low & middle income in 1991 to that in 1992?
Offer a terse response. 1.19. What is the ratio of the Mineral Rent(as % of GDP) of Portugal in 1991 to that in 1992?
Make the answer very short. 2.24. What is the ratio of the Mineral Rent(as % of GDP) in Romania in 1991 to that in 1992?
Ensure brevity in your answer.  1.09. What is the ratio of the Mineral Rent(as % of GDP) in High income: OECD in 1991 to that in 1993?
Provide a succinct answer. 1.67. What is the ratio of the Mineral Rent(as % of GDP) in Low & middle income in 1991 to that in 1993?
Offer a terse response. 1.82. What is the ratio of the Mineral Rent(as % of GDP) of Portugal in 1991 to that in 1993?
Your response must be concise. 95.13. What is the ratio of the Mineral Rent(as % of GDP) in Romania in 1991 to that in 1993?
Give a very brief answer. 2.52. What is the ratio of the Mineral Rent(as % of GDP) of High income: OECD in 1991 to that in 1994?
Provide a short and direct response. 1.3. What is the ratio of the Mineral Rent(as % of GDP) in Low & middle income in 1991 to that in 1994?
Your answer should be very brief. 1.61. What is the ratio of the Mineral Rent(as % of GDP) of Portugal in 1991 to that in 1994?
Ensure brevity in your answer.  1.98. What is the ratio of the Mineral Rent(as % of GDP) of Romania in 1991 to that in 1994?
Ensure brevity in your answer.  1.62. What is the ratio of the Mineral Rent(as % of GDP) of High income: OECD in 1991 to that in 1995?
Your answer should be compact. 1.08. What is the ratio of the Mineral Rent(as % of GDP) in Low & middle income in 1991 to that in 1995?
Make the answer very short. 1.6. What is the ratio of the Mineral Rent(as % of GDP) in Portugal in 1991 to that in 1995?
Your answer should be compact. 0.63. What is the ratio of the Mineral Rent(as % of GDP) of Romania in 1991 to that in 1995?
Your response must be concise. 1.21. What is the ratio of the Mineral Rent(as % of GDP) in High income: OECD in 1991 to that in 1997?
Ensure brevity in your answer.  1.17. What is the ratio of the Mineral Rent(as % of GDP) of Low & middle income in 1991 to that in 1997?
Your answer should be very brief. 2.05. What is the ratio of the Mineral Rent(as % of GDP) in Portugal in 1991 to that in 1997?
Ensure brevity in your answer.  7.79. What is the ratio of the Mineral Rent(as % of GDP) in Romania in 1991 to that in 1997?
Provide a short and direct response. 2.04. What is the ratio of the Mineral Rent(as % of GDP) in High income: OECD in 1991 to that in 2004?
Provide a succinct answer. 0.73. What is the ratio of the Mineral Rent(as % of GDP) of Low & middle income in 1991 to that in 2004?
Offer a terse response. 0.97. What is the ratio of the Mineral Rent(as % of GDP) of Portugal in 1991 to that in 2004?
Ensure brevity in your answer.  1.18. What is the ratio of the Mineral Rent(as % of GDP) in Romania in 1991 to that in 2004?
Your answer should be compact. 3.26. What is the ratio of the Mineral Rent(as % of GDP) of High income: OECD in 1992 to that in 1993?
Provide a succinct answer. 1.46. What is the ratio of the Mineral Rent(as % of GDP) of Low & middle income in 1992 to that in 1993?
Your answer should be very brief. 1.53. What is the ratio of the Mineral Rent(as % of GDP) of Portugal in 1992 to that in 1993?
Keep it short and to the point. 42.38. What is the ratio of the Mineral Rent(as % of GDP) of Romania in 1992 to that in 1993?
Keep it short and to the point. 2.3. What is the ratio of the Mineral Rent(as % of GDP) of High income: OECD in 1992 to that in 1994?
Provide a short and direct response. 1.13. What is the ratio of the Mineral Rent(as % of GDP) of Low & middle income in 1992 to that in 1994?
Give a very brief answer. 1.35. What is the ratio of the Mineral Rent(as % of GDP) of Portugal in 1992 to that in 1994?
Provide a succinct answer. 0.88. What is the ratio of the Mineral Rent(as % of GDP) of Romania in 1992 to that in 1994?
Offer a terse response. 1.48. What is the ratio of the Mineral Rent(as % of GDP) in High income: OECD in 1992 to that in 1995?
Keep it short and to the point. 0.94. What is the ratio of the Mineral Rent(as % of GDP) of Low & middle income in 1992 to that in 1995?
Your answer should be very brief. 1.34. What is the ratio of the Mineral Rent(as % of GDP) in Portugal in 1992 to that in 1995?
Your response must be concise. 0.28. What is the ratio of the Mineral Rent(as % of GDP) of Romania in 1992 to that in 1995?
Offer a terse response. 1.1. What is the ratio of the Mineral Rent(as % of GDP) in High income: OECD in 1992 to that in 1997?
Offer a terse response. 1.02. What is the ratio of the Mineral Rent(as % of GDP) in Low & middle income in 1992 to that in 1997?
Your answer should be compact. 1.72. What is the ratio of the Mineral Rent(as % of GDP) in Portugal in 1992 to that in 1997?
Your answer should be very brief. 3.47. What is the ratio of the Mineral Rent(as % of GDP) of Romania in 1992 to that in 1997?
Make the answer very short. 1.87. What is the ratio of the Mineral Rent(as % of GDP) in High income: OECD in 1992 to that in 2004?
Your response must be concise. 0.64. What is the ratio of the Mineral Rent(as % of GDP) of Low & middle income in 1992 to that in 2004?
Make the answer very short. 0.81. What is the ratio of the Mineral Rent(as % of GDP) of Portugal in 1992 to that in 2004?
Your answer should be very brief. 0.52. What is the ratio of the Mineral Rent(as % of GDP) of Romania in 1992 to that in 2004?
Offer a terse response. 2.98. What is the ratio of the Mineral Rent(as % of GDP) of High income: OECD in 1993 to that in 1994?
Your response must be concise. 0.78. What is the ratio of the Mineral Rent(as % of GDP) of Low & middle income in 1993 to that in 1994?
Keep it short and to the point. 0.88. What is the ratio of the Mineral Rent(as % of GDP) of Portugal in 1993 to that in 1994?
Ensure brevity in your answer.  0.02. What is the ratio of the Mineral Rent(as % of GDP) in Romania in 1993 to that in 1994?
Provide a succinct answer. 0.64. What is the ratio of the Mineral Rent(as % of GDP) of High income: OECD in 1993 to that in 1995?
Make the answer very short. 0.64. What is the ratio of the Mineral Rent(as % of GDP) in Low & middle income in 1993 to that in 1995?
Offer a very short reply. 0.88. What is the ratio of the Mineral Rent(as % of GDP) in Portugal in 1993 to that in 1995?
Your answer should be very brief. 0.01. What is the ratio of the Mineral Rent(as % of GDP) in Romania in 1993 to that in 1995?
Provide a short and direct response. 0.48. What is the ratio of the Mineral Rent(as % of GDP) of High income: OECD in 1993 to that in 1997?
Offer a terse response. 0.7. What is the ratio of the Mineral Rent(as % of GDP) in Low & middle income in 1993 to that in 1997?
Ensure brevity in your answer.  1.13. What is the ratio of the Mineral Rent(as % of GDP) in Portugal in 1993 to that in 1997?
Make the answer very short. 0.08. What is the ratio of the Mineral Rent(as % of GDP) in Romania in 1993 to that in 1997?
Make the answer very short. 0.81. What is the ratio of the Mineral Rent(as % of GDP) in High income: OECD in 1993 to that in 2004?
Your answer should be very brief. 0.44. What is the ratio of the Mineral Rent(as % of GDP) in Low & middle income in 1993 to that in 2004?
Give a very brief answer. 0.53. What is the ratio of the Mineral Rent(as % of GDP) in Portugal in 1993 to that in 2004?
Offer a very short reply. 0.01. What is the ratio of the Mineral Rent(as % of GDP) of Romania in 1993 to that in 2004?
Provide a succinct answer. 1.3. What is the ratio of the Mineral Rent(as % of GDP) of High income: OECD in 1994 to that in 1995?
Make the answer very short. 0.83. What is the ratio of the Mineral Rent(as % of GDP) of Low & middle income in 1994 to that in 1995?
Your response must be concise. 1. What is the ratio of the Mineral Rent(as % of GDP) in Portugal in 1994 to that in 1995?
Offer a very short reply. 0.32. What is the ratio of the Mineral Rent(as % of GDP) in Romania in 1994 to that in 1995?
Offer a terse response. 0.75. What is the ratio of the Mineral Rent(as % of GDP) in High income: OECD in 1994 to that in 1997?
Your answer should be very brief. 0.9. What is the ratio of the Mineral Rent(as % of GDP) in Low & middle income in 1994 to that in 1997?
Your answer should be very brief. 1.28. What is the ratio of the Mineral Rent(as % of GDP) in Portugal in 1994 to that in 1997?
Make the answer very short. 3.93. What is the ratio of the Mineral Rent(as % of GDP) in Romania in 1994 to that in 1997?
Provide a succinct answer. 1.26. What is the ratio of the Mineral Rent(as % of GDP) of High income: OECD in 1994 to that in 2004?
Your answer should be compact. 0.56. What is the ratio of the Mineral Rent(as % of GDP) of Low & middle income in 1994 to that in 2004?
Ensure brevity in your answer.  0.61. What is the ratio of the Mineral Rent(as % of GDP) of Portugal in 1994 to that in 2004?
Keep it short and to the point. 0.59. What is the ratio of the Mineral Rent(as % of GDP) of Romania in 1994 to that in 2004?
Provide a succinct answer. 2.01. What is the ratio of the Mineral Rent(as % of GDP) in High income: OECD in 1995 to that in 1997?
Give a very brief answer. 1.08. What is the ratio of the Mineral Rent(as % of GDP) of Low & middle income in 1995 to that in 1997?
Your answer should be compact. 1.28. What is the ratio of the Mineral Rent(as % of GDP) in Portugal in 1995 to that in 1997?
Ensure brevity in your answer.  12.45. What is the ratio of the Mineral Rent(as % of GDP) of Romania in 1995 to that in 1997?
Give a very brief answer. 1.69. What is the ratio of the Mineral Rent(as % of GDP) in High income: OECD in 1995 to that in 2004?
Offer a terse response. 0.68. What is the ratio of the Mineral Rent(as % of GDP) of Low & middle income in 1995 to that in 2004?
Your response must be concise. 0.61. What is the ratio of the Mineral Rent(as % of GDP) of Portugal in 1995 to that in 2004?
Offer a very short reply. 1.88. What is the ratio of the Mineral Rent(as % of GDP) in Romania in 1995 to that in 2004?
Keep it short and to the point. 2.7. What is the ratio of the Mineral Rent(as % of GDP) of High income: OECD in 1997 to that in 2004?
Offer a very short reply. 0.63. What is the ratio of the Mineral Rent(as % of GDP) in Low & middle income in 1997 to that in 2004?
Provide a short and direct response. 0.47. What is the ratio of the Mineral Rent(as % of GDP) in Portugal in 1997 to that in 2004?
Your answer should be compact. 0.15. What is the ratio of the Mineral Rent(as % of GDP) in Romania in 1997 to that in 2004?
Keep it short and to the point. 1.6. What is the difference between the highest and the second highest Mineral Rent(as % of GDP) in High income: OECD?
Give a very brief answer. 0.02. What is the difference between the highest and the second highest Mineral Rent(as % of GDP) in Low & middle income?
Offer a terse response. 0.01. What is the difference between the highest and the second highest Mineral Rent(as % of GDP) in Portugal?
Give a very brief answer. 0.02. What is the difference between the highest and the second highest Mineral Rent(as % of GDP) in Romania?
Offer a very short reply. 0.01. What is the difference between the highest and the lowest Mineral Rent(as % of GDP) of High income: OECD?
Offer a very short reply. 0.05. What is the difference between the highest and the lowest Mineral Rent(as % of GDP) of Low & middle income?
Your response must be concise. 0.26. What is the difference between the highest and the lowest Mineral Rent(as % of GDP) of Portugal?
Keep it short and to the point. 0.06. What is the difference between the highest and the lowest Mineral Rent(as % of GDP) of Romania?
Your answer should be very brief. 0.11. 